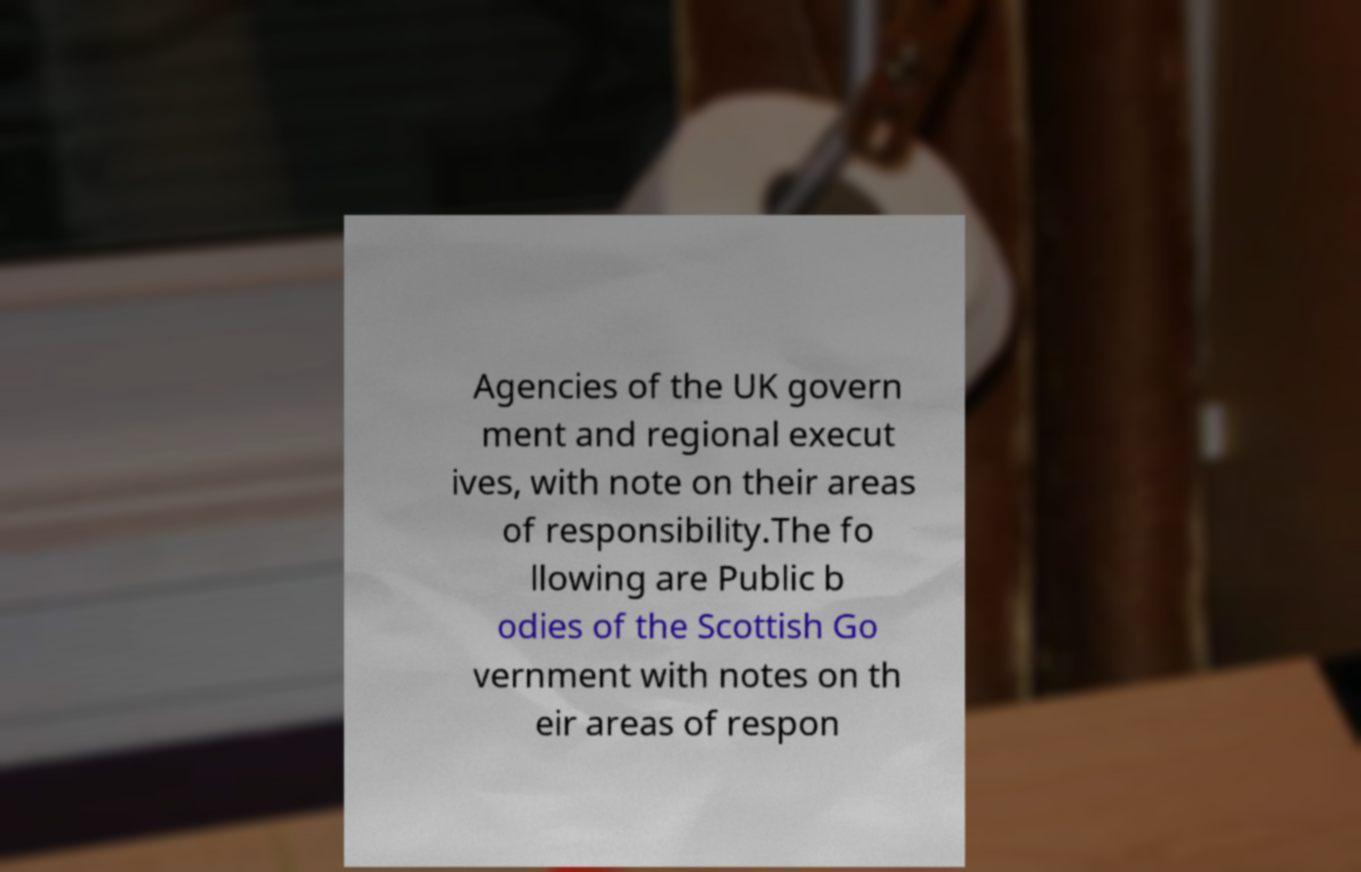Could you assist in decoding the text presented in this image and type it out clearly? Agencies of the UK govern ment and regional execut ives, with note on their areas of responsibility.The fo llowing are Public b odies of the Scottish Go vernment with notes on th eir areas of respon 